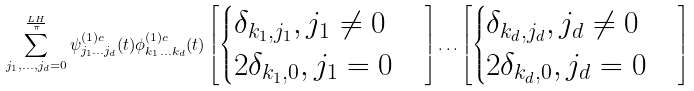Convert formula to latex. <formula><loc_0><loc_0><loc_500><loc_500>\sum _ { j _ { 1 } , \dots , j _ { d } = 0 } ^ { \frac { L H } { \pi } } \psi ^ { ( 1 ) c } _ { j _ { 1 } \dots j _ { d } } ( t ) \phi ^ { ( 1 ) c } _ { k _ { 1 } \dots k _ { d } } ( t ) \left [ \begin{cases} \delta _ { k _ { 1 } , j _ { 1 } } , j _ { 1 } \neq 0 \\ 2 \delta _ { k _ { 1 } , 0 } , j _ { 1 } = 0 \end{cases} \right ] \dots \left [ \begin{cases} \delta _ { k _ { d } , j _ { d } } , j _ { d } \neq 0 \\ 2 \delta _ { k _ { d } , 0 } , j _ { d } = 0 \end{cases} \right ]</formula> 